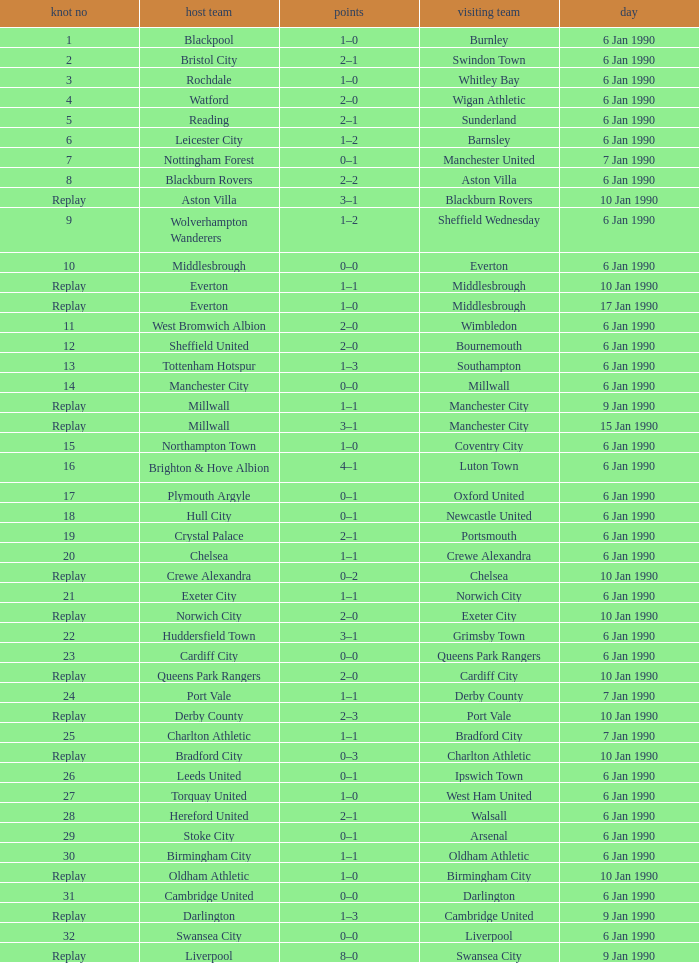Could you parse the entire table as a dict? {'header': ['knot no', 'host team', 'points', 'visiting team', 'day'], 'rows': [['1', 'Blackpool', '1–0', 'Burnley', '6 Jan 1990'], ['2', 'Bristol City', '2–1', 'Swindon Town', '6 Jan 1990'], ['3', 'Rochdale', '1–0', 'Whitley Bay', '6 Jan 1990'], ['4', 'Watford', '2–0', 'Wigan Athletic', '6 Jan 1990'], ['5', 'Reading', '2–1', 'Sunderland', '6 Jan 1990'], ['6', 'Leicester City', '1–2', 'Barnsley', '6 Jan 1990'], ['7', 'Nottingham Forest', '0–1', 'Manchester United', '7 Jan 1990'], ['8', 'Blackburn Rovers', '2–2', 'Aston Villa', '6 Jan 1990'], ['Replay', 'Aston Villa', '3–1', 'Blackburn Rovers', '10 Jan 1990'], ['9', 'Wolverhampton Wanderers', '1–2', 'Sheffield Wednesday', '6 Jan 1990'], ['10', 'Middlesbrough', '0–0', 'Everton', '6 Jan 1990'], ['Replay', 'Everton', '1–1', 'Middlesbrough', '10 Jan 1990'], ['Replay', 'Everton', '1–0', 'Middlesbrough', '17 Jan 1990'], ['11', 'West Bromwich Albion', '2–0', 'Wimbledon', '6 Jan 1990'], ['12', 'Sheffield United', '2–0', 'Bournemouth', '6 Jan 1990'], ['13', 'Tottenham Hotspur', '1–3', 'Southampton', '6 Jan 1990'], ['14', 'Manchester City', '0–0', 'Millwall', '6 Jan 1990'], ['Replay', 'Millwall', '1–1', 'Manchester City', '9 Jan 1990'], ['Replay', 'Millwall', '3–1', 'Manchester City', '15 Jan 1990'], ['15', 'Northampton Town', '1–0', 'Coventry City', '6 Jan 1990'], ['16', 'Brighton & Hove Albion', '4–1', 'Luton Town', '6 Jan 1990'], ['17', 'Plymouth Argyle', '0–1', 'Oxford United', '6 Jan 1990'], ['18', 'Hull City', '0–1', 'Newcastle United', '6 Jan 1990'], ['19', 'Crystal Palace', '2–1', 'Portsmouth', '6 Jan 1990'], ['20', 'Chelsea', '1–1', 'Crewe Alexandra', '6 Jan 1990'], ['Replay', 'Crewe Alexandra', '0–2', 'Chelsea', '10 Jan 1990'], ['21', 'Exeter City', '1–1', 'Norwich City', '6 Jan 1990'], ['Replay', 'Norwich City', '2–0', 'Exeter City', '10 Jan 1990'], ['22', 'Huddersfield Town', '3–1', 'Grimsby Town', '6 Jan 1990'], ['23', 'Cardiff City', '0–0', 'Queens Park Rangers', '6 Jan 1990'], ['Replay', 'Queens Park Rangers', '2–0', 'Cardiff City', '10 Jan 1990'], ['24', 'Port Vale', '1–1', 'Derby County', '7 Jan 1990'], ['Replay', 'Derby County', '2–3', 'Port Vale', '10 Jan 1990'], ['25', 'Charlton Athletic', '1–1', 'Bradford City', '7 Jan 1990'], ['Replay', 'Bradford City', '0–3', 'Charlton Athletic', '10 Jan 1990'], ['26', 'Leeds United', '0–1', 'Ipswich Town', '6 Jan 1990'], ['27', 'Torquay United', '1–0', 'West Ham United', '6 Jan 1990'], ['28', 'Hereford United', '2–1', 'Walsall', '6 Jan 1990'], ['29', 'Stoke City', '0–1', 'Arsenal', '6 Jan 1990'], ['30', 'Birmingham City', '1–1', 'Oldham Athletic', '6 Jan 1990'], ['Replay', 'Oldham Athletic', '1–0', 'Birmingham City', '10 Jan 1990'], ['31', 'Cambridge United', '0–0', 'Darlington', '6 Jan 1990'], ['Replay', 'Darlington', '1–3', 'Cambridge United', '9 Jan 1990'], ['32', 'Swansea City', '0–0', 'Liverpool', '6 Jan 1990'], ['Replay', 'Liverpool', '8–0', 'Swansea City', '9 Jan 1990']]} What date did home team liverpool play? 9 Jan 1990. 